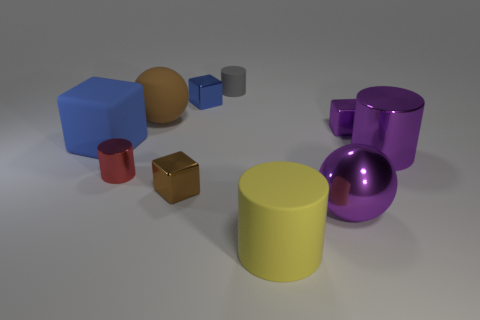The small rubber cylinder is what color?
Your answer should be very brief. Gray. How many small red metallic things have the same shape as the gray matte thing?
Keep it short and to the point. 1. What shape is the yellow matte thing?
Your answer should be very brief. Cylinder. Are there an equal number of tiny shiny objects that are to the left of the purple shiny cylinder and large things?
Offer a terse response. No. Is there any other thing that has the same material as the brown ball?
Offer a terse response. Yes. Is the material of the large purple cylinder on the right side of the large blue block the same as the large block?
Offer a very short reply. No. Is the number of large cylinders that are in front of the shiny ball less than the number of cyan metal balls?
Give a very brief answer. No. How many metal things are either large brown blocks or tiny purple objects?
Your answer should be very brief. 1. Is the color of the large shiny sphere the same as the small rubber thing?
Offer a very short reply. No. Are there any other things that are the same color as the tiny matte thing?
Offer a terse response. No. 